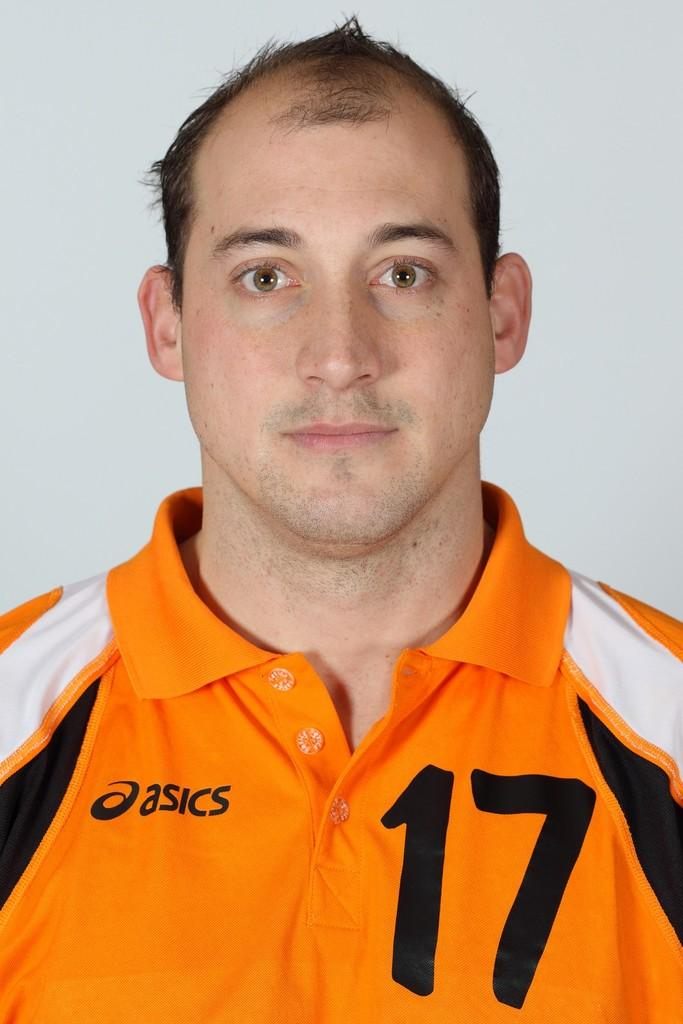Provide a one-sentence caption for the provided image. A man wearing an Asics polo shirt with the number 17 on it poses for a photo. 